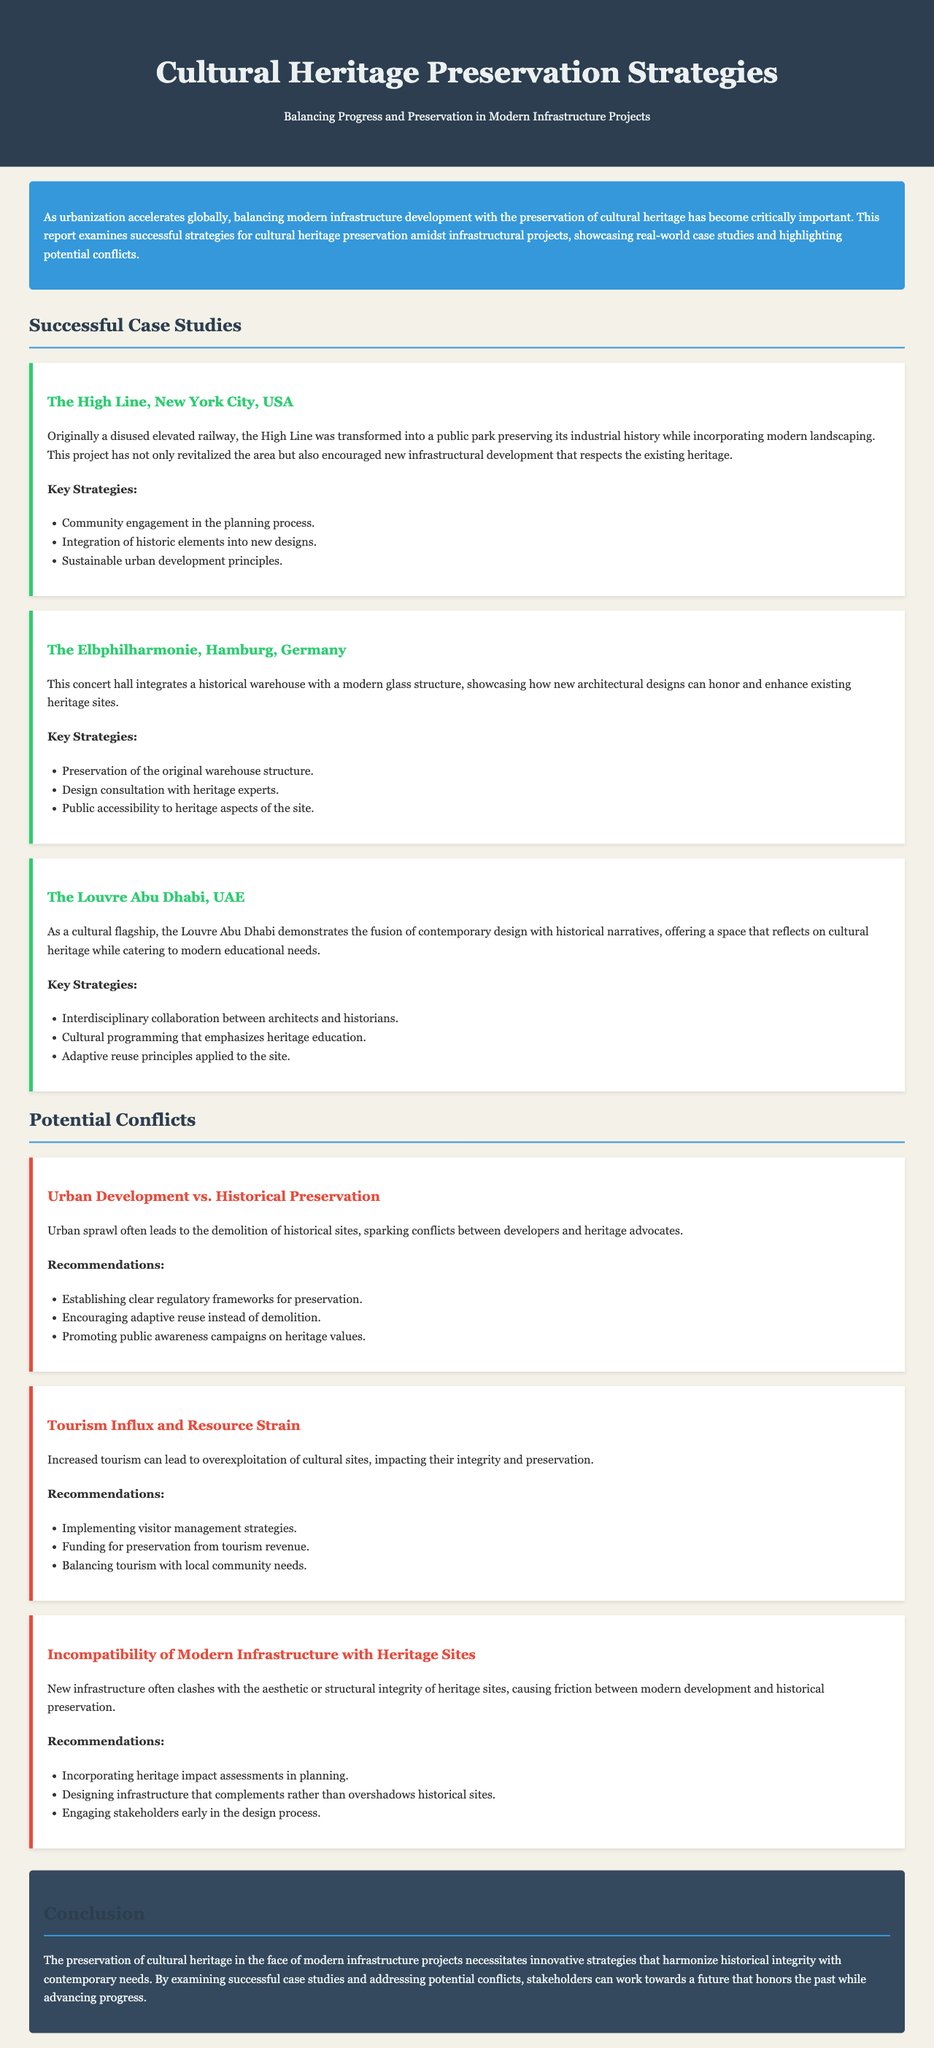what is the title of the report? The title of the report is explicitly stated in the header section.
Answer: Cultural Heritage Preservation Strategies which city is known for the High Line park? The High Line park is a notable project located in New York City.
Answer: New York City what are the key strategies used in the Elbphilharmonie project? Key strategies are listed under the case study of the Elbphilharmonie, detailing preservation techniques.
Answer: Preservation of the original warehouse structure, Design consultation with heritage experts, Public accessibility to heritage aspects of the site what is a potential conflict related to urban development? The report outlines various conflicts, including one specifically associated with urban development versus historical preservation.
Answer: Urban Development vs. Historical Preservation what is one recommendation for managing tourism impacts? The recommendations section addresses issues arising from tourism and provides specific strategies.
Answer: Implementing visitor management strategies how many case studies are highlighted in the report? The report explicitly enumerates the case studies discussed within the successful strategies section.
Answer: Three what is the focus of the conclusion section? The conclusion summarizes the primary goal and themes discussed throughout the report.
Answer: Innovative strategies that harmonize historical integrity with contemporary needs who should be engaged early in the design process according to the report? The report suggests specific parties to involve in the planning phase to mitigate conflicts.
Answer: Stakeholders 